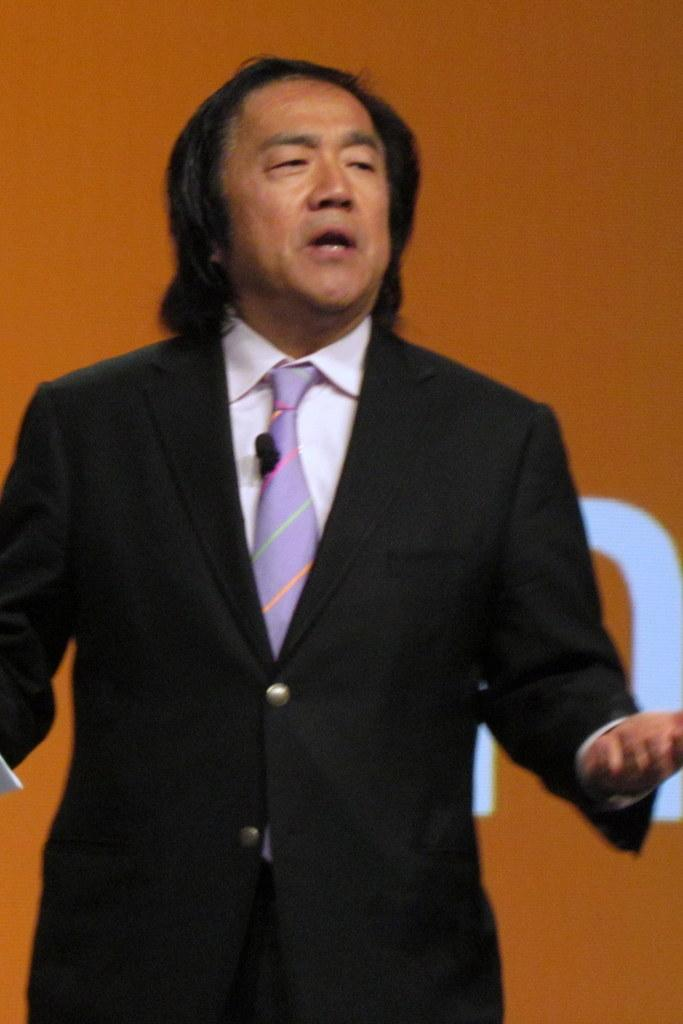What is the appearance of the man in the image? The man in the image is wearing a black suit. What is the man doing in the image? The man is standing and speaking. Which direction is the man looking in the image? The man is looking to the right. What can be seen in the background of the image? There is an orange board in the background. What is written or depicted on the orange board? There is text on the orange board. How many toes can be seen on the man's feet in the image? There is no visible indication of the man's feet or toes in the image. 